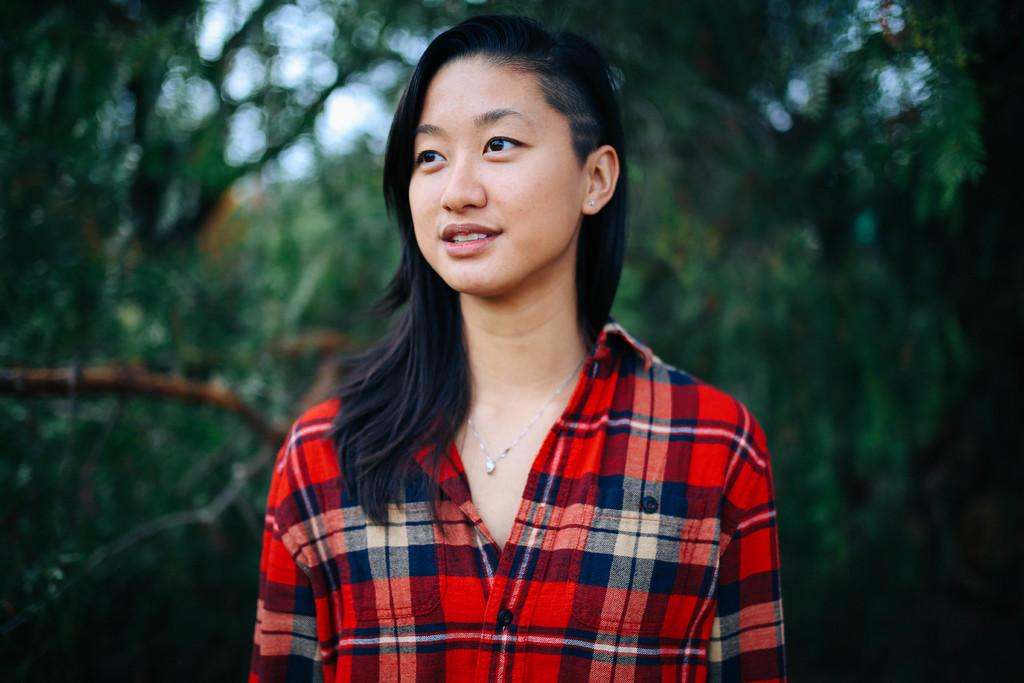Who is the main subject in the image? There is a lady in the image. What can be seen in the background of the image? There are trees and the sky visible in the background of the image. How is the background of the image depicted? The background appears to be blurred. How many beds can be seen in the image? There are no beds present in the image. Is there a glove visible on the lady's hand in the image? There is no glove visible on the lady's hand in the image. 